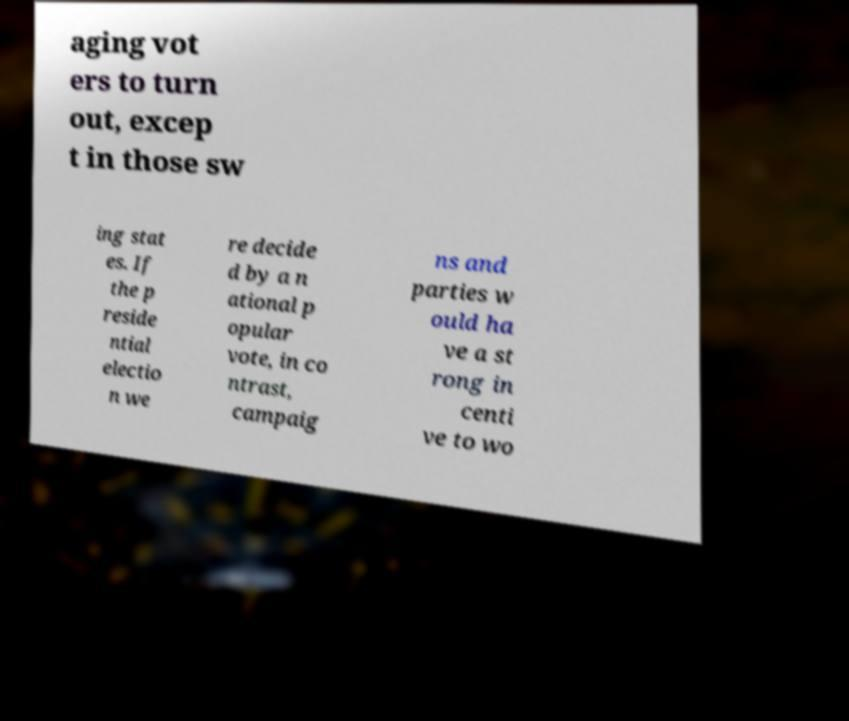There's text embedded in this image that I need extracted. Can you transcribe it verbatim? aging vot ers to turn out, excep t in those sw ing stat es. If the p reside ntial electio n we re decide d by a n ational p opular vote, in co ntrast, campaig ns and parties w ould ha ve a st rong in centi ve to wo 